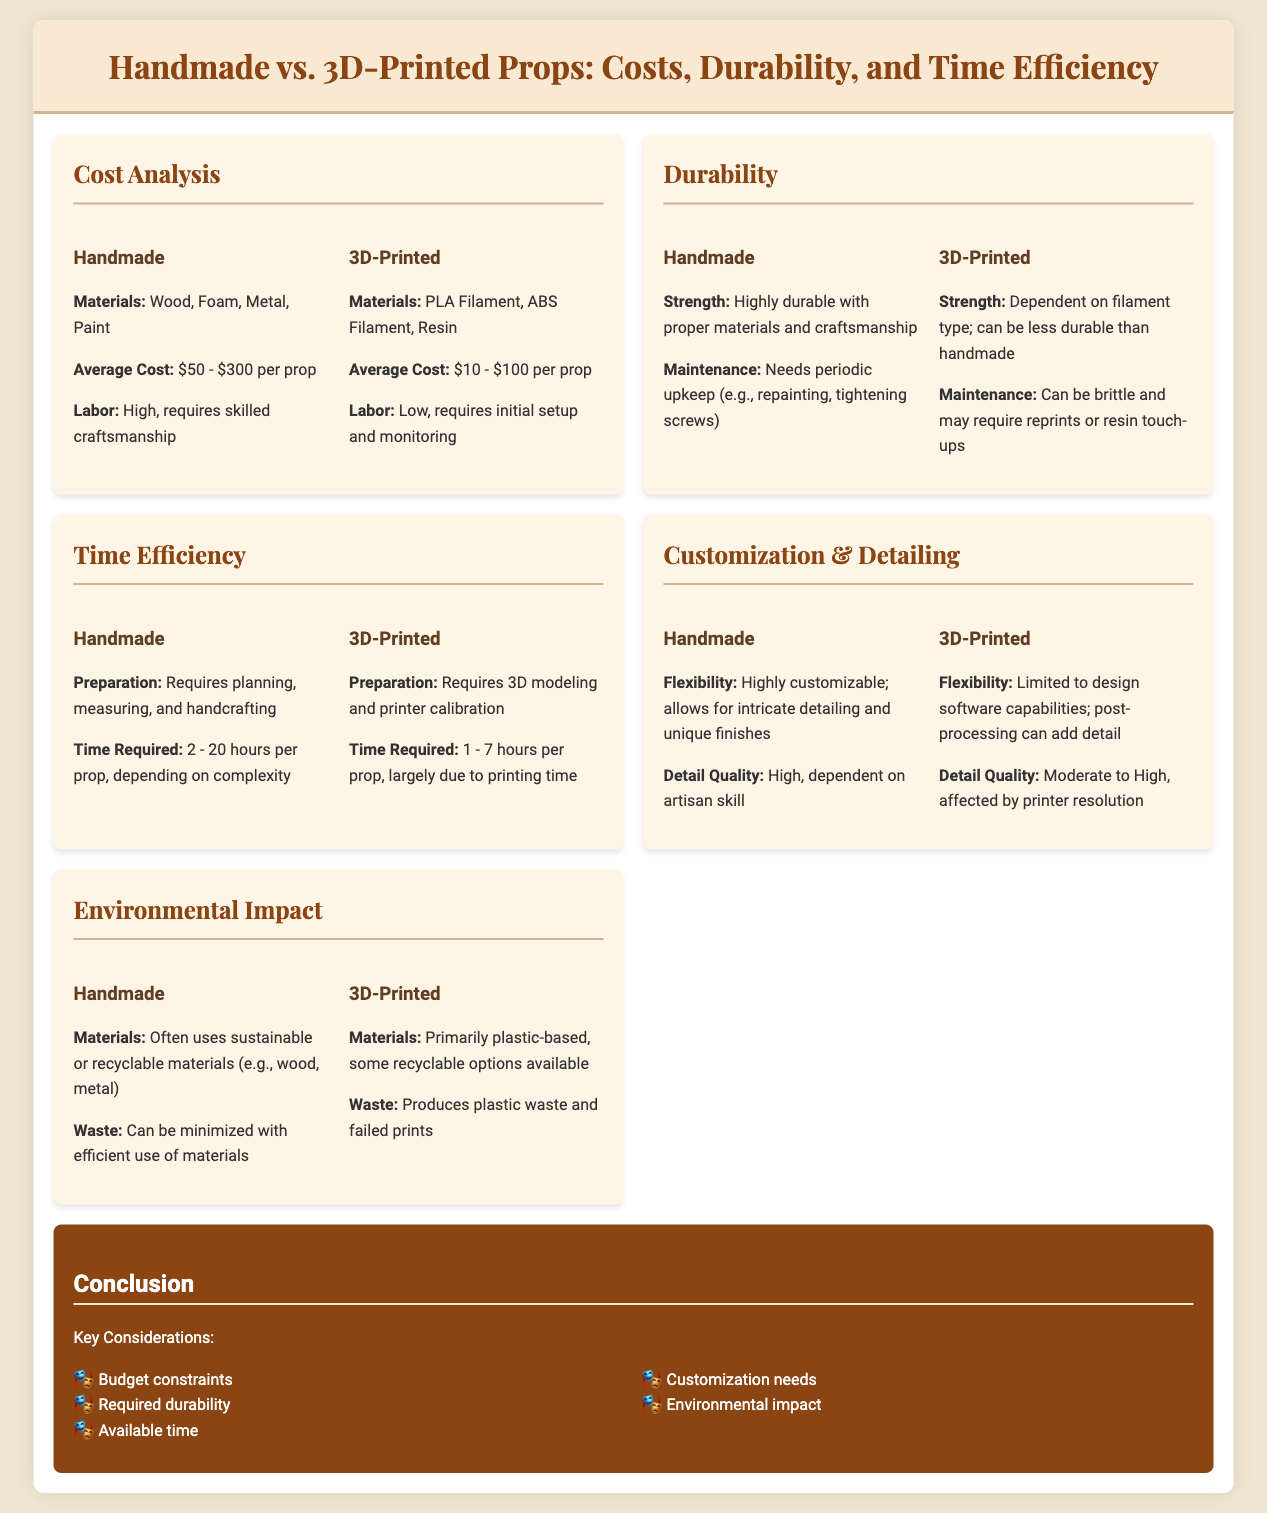What is the average cost of handmade props? The average cost of handmade props is listed in the document, which is $50 - $300 per prop.
Answer: $50 - $300 per prop What materials are used for 3D-printed props? The materials used for 3D-printed props are specified in the document as PLA Filament, ABS Filament, and Resin.
Answer: PLA Filament, ABS Filament, Resin How much time is required to create a handmade prop? The time required for a handmade prop varies and is provided in the document, which is 2 - 20 hours per prop.
Answer: 2 - 20 hours per prop Which type of props has higher maintenance needs? The document indicates that handmade props need periodic upkeep, which implies they have higher maintenance needs compared to 3D-printed props.
Answer: Handmade What is the strength characteristic of 3D-printed props? The document states that the strength of 3D-printed props is dependent on filament type and can be less durable than handmade.
Answer: Dependent on filament type; less durable than handmade Which type of props allows for more intricate detailing? The document clearly mentions that handmade props are highly customizable and allow for intricate detailing.
Answer: Handmade What impact do 3D-printed props typically have on the environment? The document describes the environmental impact, indicating that 3D-printed props produce plastic waste and failed prints.
Answer: Produces plastic waste and failed prints What is a key consideration when deciding between prop types? The document lists multiple key considerations, one of which is budget constraints.
Answer: Budget constraints 